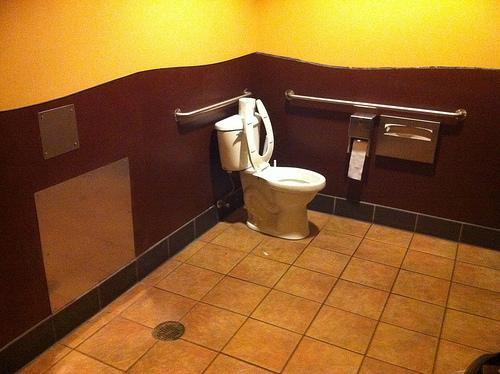Provide a brief summary of the key elements in the image. A public restroom with tiled floor, a white toilet, drain, grab bars, toilet paper dispenser, and seat protector dispenser on yellow and brown walls. List the significant elements in the image with their corresponding colors. Toilet (white), tiled floor (brown and tan), walls (yellow and brown), grab bars (stainless steel), dispensers (stainless steel). Mention the main components and color scheme that makeup the image. The image features a white toilet, yellow and brown walls, a tiled floor, stainless steel grab bars, and dispensers for toilet paper and seat protectors. In a short sentence, describe the central objects and color scheme of the image. The image showcases a public restroom with a white toilet, stainless steel fixtures, and yellow, brown, and tan colors. Briefly mention the primary objects in the image and their dominant colors. A restroom features a white toilet, stainless steel grab bars and dispensers, and tan, brown, and yellow walls and tiles. Enumerate the main objects in the image along with their colors. White toilet, tiled floor (brown and tan), drain (silver), grab bars (stainless steel), toilet paper dispenser (stainless steel), seat protector dispenser (stainless steel). In a short sentence, describe the setting of the image. This is a public bathroom with a white toilet, tiled floor, and yellow and brown walls. Write a brief description of the main aspects of the image and their respective colors. This public restroom consists of a white toilet, stainless steel grab bars and dispensers, a tiled floor, and yellow and brown walls. Write a concise description of the image's main elements, including the colors of the objects. The image displays a white toilet, grab bars, a tiled floor, and a mix of yellow and brown walls in a public restroom. Describe the scene in the image, highlighting the primary objects and their colors. A restroom scene with a white toilet on brown and tan tiled floor, surrounded by yellow and brown walls, and stainless steel grab bars and dispensers. 